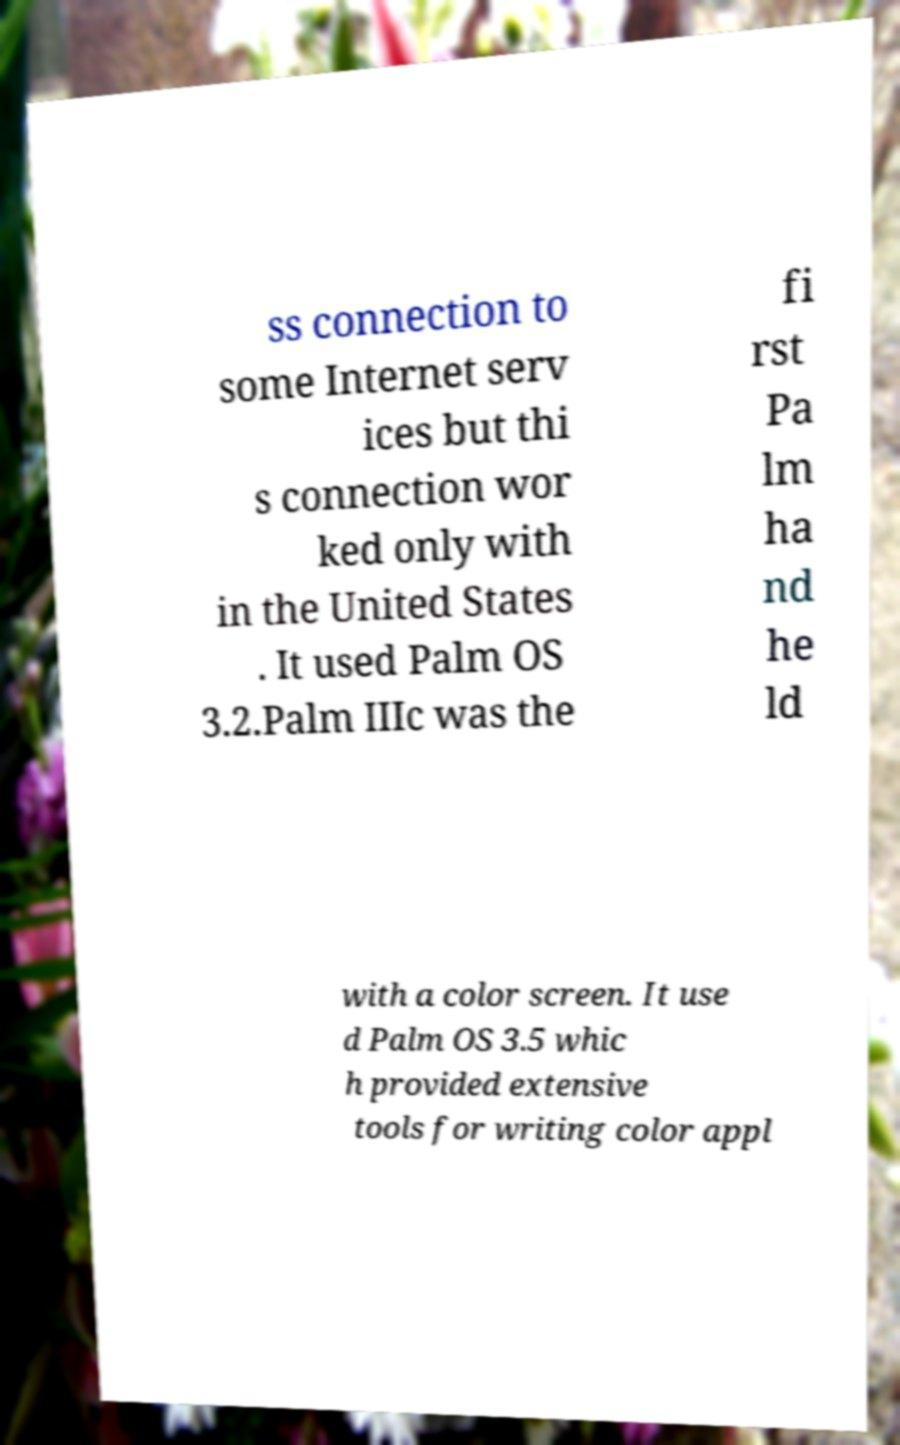What messages or text are displayed in this image? I need them in a readable, typed format. ss connection to some Internet serv ices but thi s connection wor ked only with in the United States . It used Palm OS 3.2.Palm IIIc was the fi rst Pa lm ha nd he ld with a color screen. It use d Palm OS 3.5 whic h provided extensive tools for writing color appl 